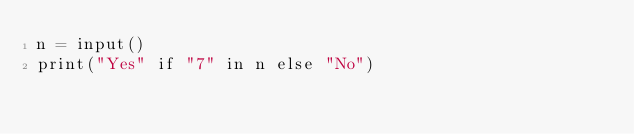Convert code to text. <code><loc_0><loc_0><loc_500><loc_500><_Python_>n = input()
print("Yes" if "7" in n else "No")</code> 